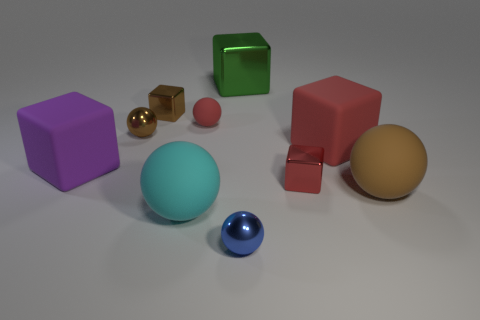What shapes are present in the image? The image contains a variety of shapes including a cylinder, cubes, spheres, and a rectangular prism. 